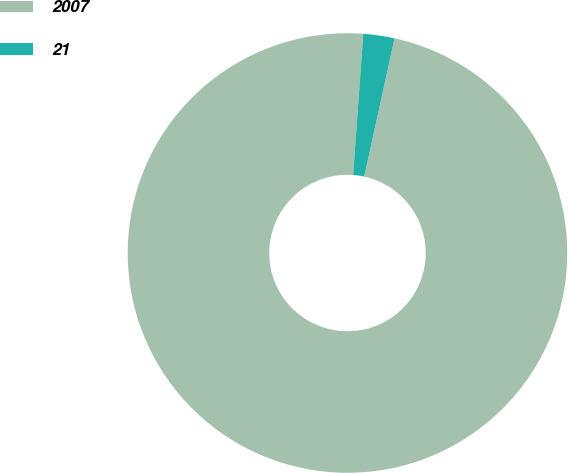<chart> <loc_0><loc_0><loc_500><loc_500><pie_chart><fcel>2007<fcel>21<nl><fcel>97.71%<fcel>2.29%<nl></chart> 